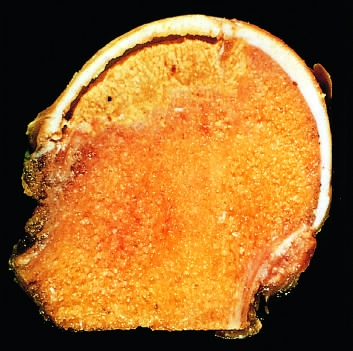s the space between the overlying articular cartilage and bone caused by trabecular compression fractures without repair?
Answer the question using a single word or phrase. Yes 